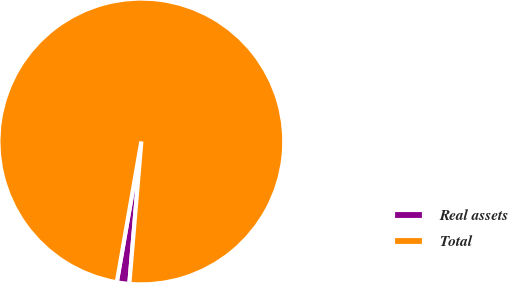Convert chart. <chart><loc_0><loc_0><loc_500><loc_500><pie_chart><fcel>Real assets<fcel>Total<nl><fcel>1.41%<fcel>98.59%<nl></chart> 